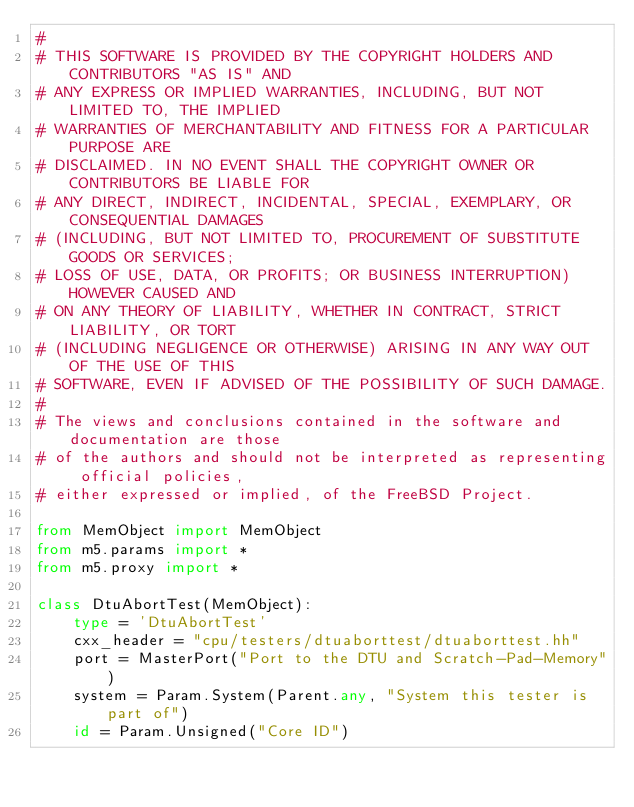<code> <loc_0><loc_0><loc_500><loc_500><_Python_>#
# THIS SOFTWARE IS PROVIDED BY THE COPYRIGHT HOLDERS AND CONTRIBUTORS "AS IS" AND
# ANY EXPRESS OR IMPLIED WARRANTIES, INCLUDING, BUT NOT LIMITED TO, THE IMPLIED
# WARRANTIES OF MERCHANTABILITY AND FITNESS FOR A PARTICULAR PURPOSE ARE
# DISCLAIMED. IN NO EVENT SHALL THE COPYRIGHT OWNER OR CONTRIBUTORS BE LIABLE FOR
# ANY DIRECT, INDIRECT, INCIDENTAL, SPECIAL, EXEMPLARY, OR CONSEQUENTIAL DAMAGES
# (INCLUDING, BUT NOT LIMITED TO, PROCUREMENT OF SUBSTITUTE GOODS OR SERVICES;
# LOSS OF USE, DATA, OR PROFITS; OR BUSINESS INTERRUPTION) HOWEVER CAUSED AND
# ON ANY THEORY OF LIABILITY, WHETHER IN CONTRACT, STRICT LIABILITY, OR TORT
# (INCLUDING NEGLIGENCE OR OTHERWISE) ARISING IN ANY WAY OUT OF THE USE OF THIS
# SOFTWARE, EVEN IF ADVISED OF THE POSSIBILITY OF SUCH DAMAGE.
#
# The views and conclusions contained in the software and documentation are those
# of the authors and should not be interpreted as representing official policies,
# either expressed or implied, of the FreeBSD Project.

from MemObject import MemObject
from m5.params import *
from m5.proxy import *

class DtuAbortTest(MemObject):
    type = 'DtuAbortTest'
    cxx_header = "cpu/testers/dtuaborttest/dtuaborttest.hh"
    port = MasterPort("Port to the DTU and Scratch-Pad-Memory")
    system = Param.System(Parent.any, "System this tester is part of")
    id = Param.Unsigned("Core ID")
</code> 